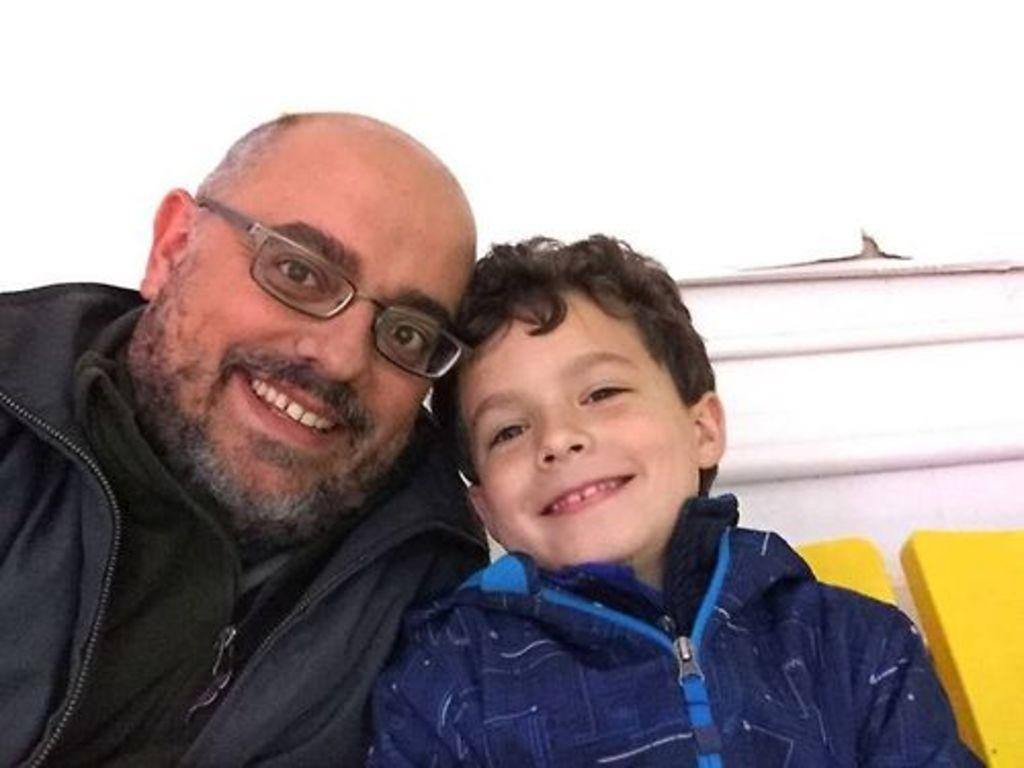Who is present in the image? There is a man and a boy in the image. What are the man and the boy doing in the image? Both the man and the boy are seated. Can you describe the man's appearance? The man is wearing spectacles. How do the man and the boy appear to feel in the image? There is a smile on the faces of the man and the boy. What is the color of the background in the image? The background of the image is white. What is the man's favorite hobby, and how does it relate to the image? The facts provided do not mention the man's hobbies, so we cannot determine his favorite hobby or how it relates to the image. 